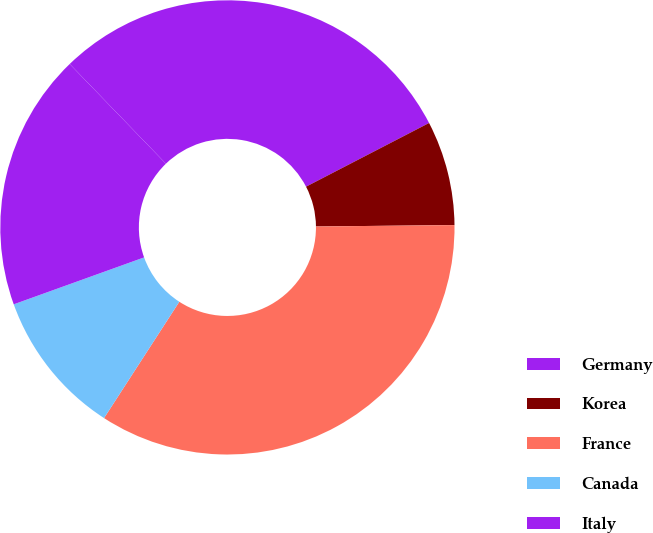<chart> <loc_0><loc_0><loc_500><loc_500><pie_chart><fcel>Germany<fcel>Korea<fcel>France<fcel>Canada<fcel>Italy<nl><fcel>29.61%<fcel>7.44%<fcel>34.3%<fcel>10.36%<fcel>18.28%<nl></chart> 